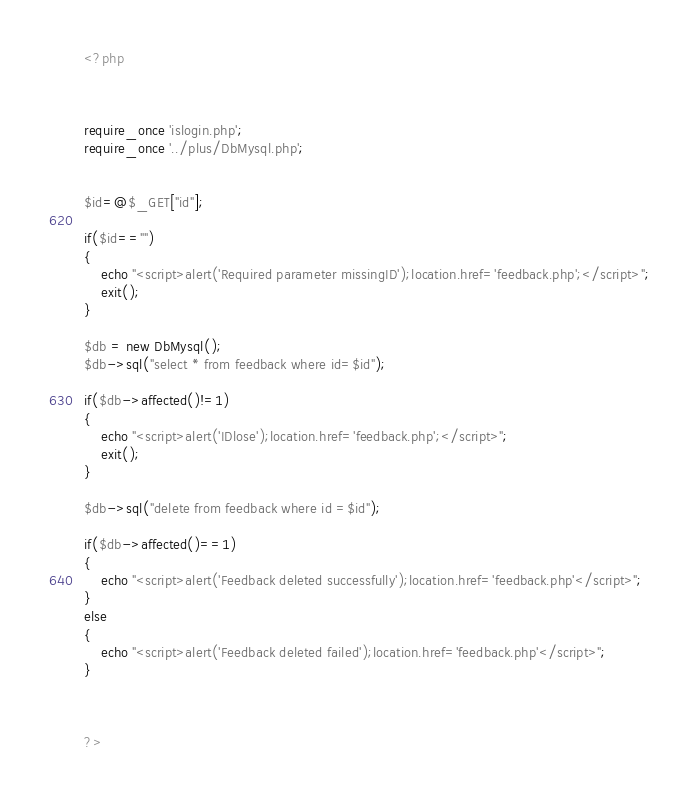<code> <loc_0><loc_0><loc_500><loc_500><_PHP_><?php



require_once 'islogin.php';
require_once '../plus/DbMysql.php';


$id=@$_GET["id"];

if($id=="")
{
    echo "<script>alert('Required parameter missingID');location.href='feedback.php';</script>";
    exit();
}

$db = new DbMysql();
$db->sql("select * from feedback where id=$id");

if($db->affected()!=1)
{
    echo "<script>alert('IDlose');location.href='feedback.php';</script>";
    exit();
}

$db->sql("delete from feedback where id =$id");

if($db->affected()==1)
{
    echo "<script>alert('Feedback deleted successfully');location.href='feedback.php'</script>";
}
else
{
    echo "<script>alert('Feedback deleted failed');location.href='feedback.php'</script>";
}



?>
</code> 